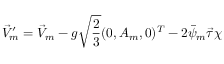Convert formula to latex. <formula><loc_0><loc_0><loc_500><loc_500>\vec { V } _ { m } ^ { \prime } = \vec { V } _ { m } - g \sqrt { \frac { 2 } { 3 } } ( 0 , A _ { m } , 0 ) ^ { T } - 2 \bar { \psi } _ { m } \vec { \tau } \chi</formula> 